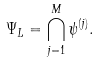<formula> <loc_0><loc_0><loc_500><loc_500>\Psi _ { L } = \bigcap _ { j = 1 } ^ { M } \psi ^ { ( j ) } .</formula> 